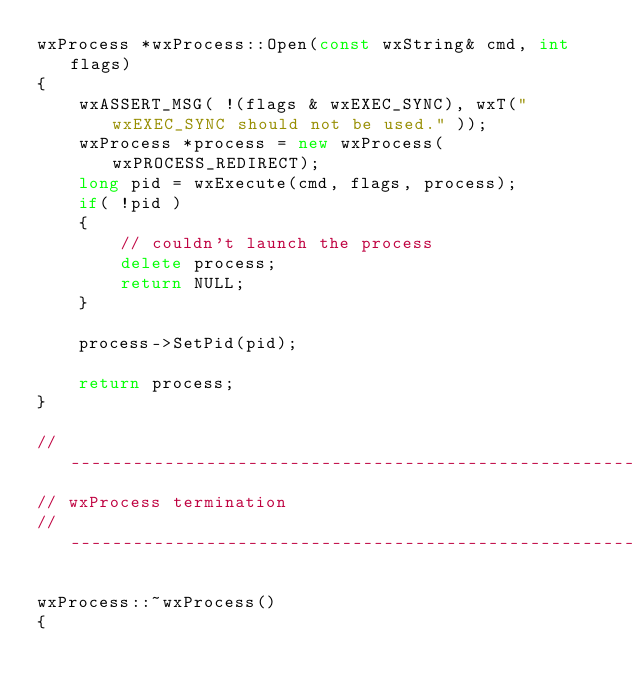Convert code to text. <code><loc_0><loc_0><loc_500><loc_500><_C++_>wxProcess *wxProcess::Open(const wxString& cmd, int flags)
{
    wxASSERT_MSG( !(flags & wxEXEC_SYNC), wxT("wxEXEC_SYNC should not be used." ));
    wxProcess *process = new wxProcess(wxPROCESS_REDIRECT);
    long pid = wxExecute(cmd, flags, process);
    if( !pid )
    {
        // couldn't launch the process
        delete process;
        return NULL;
    }

    process->SetPid(pid);

    return process;
}

// ----------------------------------------------------------------------------
// wxProcess termination
// ----------------------------------------------------------------------------

wxProcess::~wxProcess()
{</code> 